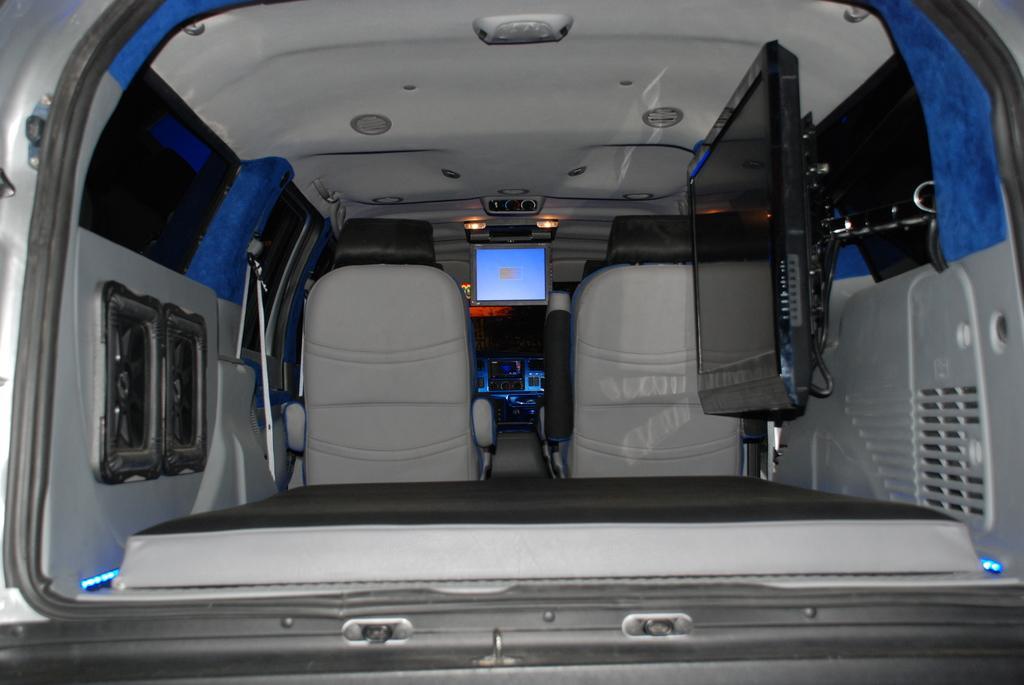Could you give a brief overview of what you see in this image? In this picture we can see seats, televisions, lights and these all are inside a vehicle. 